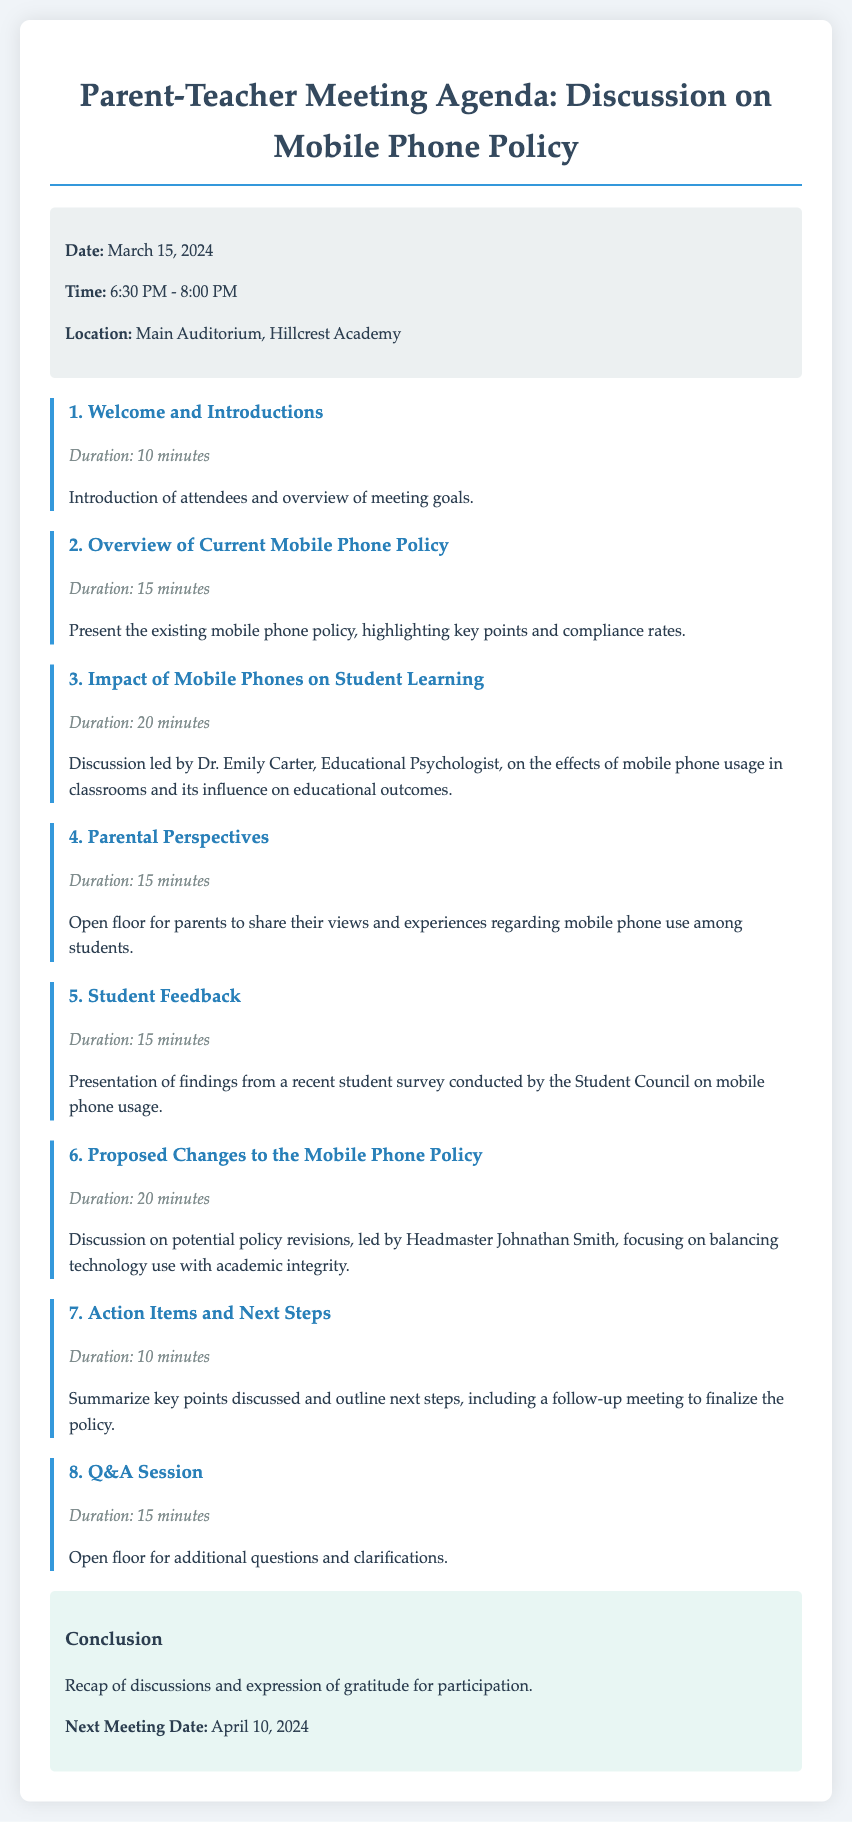What is the date of the meeting? The date of the meeting is specified in the meeting info section of the document.
Answer: March 15, 2024 Who is leading the discussion on the impact of mobile phones on student learning? The document states that the discussion on the impact of mobile phones will be led by Dr. Emily Carter, an Educational Psychologist.
Answer: Dr. Emily Carter How long is the Q&A session scheduled for? The duration of the Q&A session is provided under its agenda item, indicating the time allocated for this part of the meeting.
Answer: 15 minutes What are the action items and next steps? The action items and next steps are summarized at the end of the meeting agenda to outline the conclusions and future actions.
Answer: Summarize key points discussed and outline next steps When is the next meeting scheduled? The next meeting date is mentioned under the conclusion section, providing information for follow-up.
Answer: April 10, 2024 